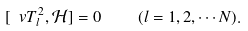<formula> <loc_0><loc_0><loc_500><loc_500>[ \ v { T } _ { l } ^ { 2 } , { \mathcal { H } } ] = 0 \quad ( l = 1 , 2 , \cdots N ) .</formula> 